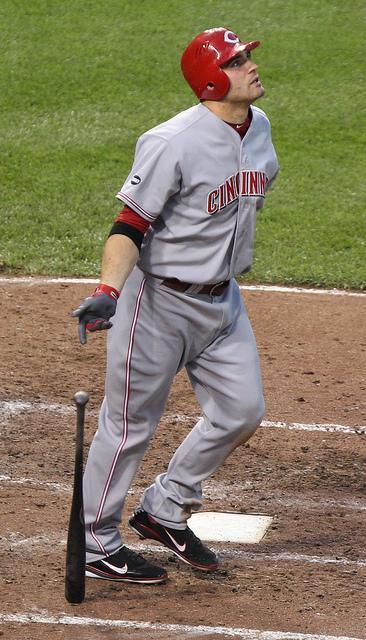How many umbrellas in this picture are yellow?
Give a very brief answer. 0. 